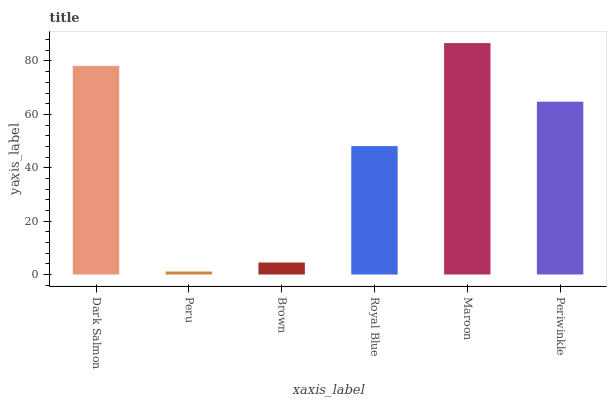Is Peru the minimum?
Answer yes or no. Yes. Is Maroon the maximum?
Answer yes or no. Yes. Is Brown the minimum?
Answer yes or no. No. Is Brown the maximum?
Answer yes or no. No. Is Brown greater than Peru?
Answer yes or no. Yes. Is Peru less than Brown?
Answer yes or no. Yes. Is Peru greater than Brown?
Answer yes or no. No. Is Brown less than Peru?
Answer yes or no. No. Is Periwinkle the high median?
Answer yes or no. Yes. Is Royal Blue the low median?
Answer yes or no. Yes. Is Dark Salmon the high median?
Answer yes or no. No. Is Maroon the low median?
Answer yes or no. No. 